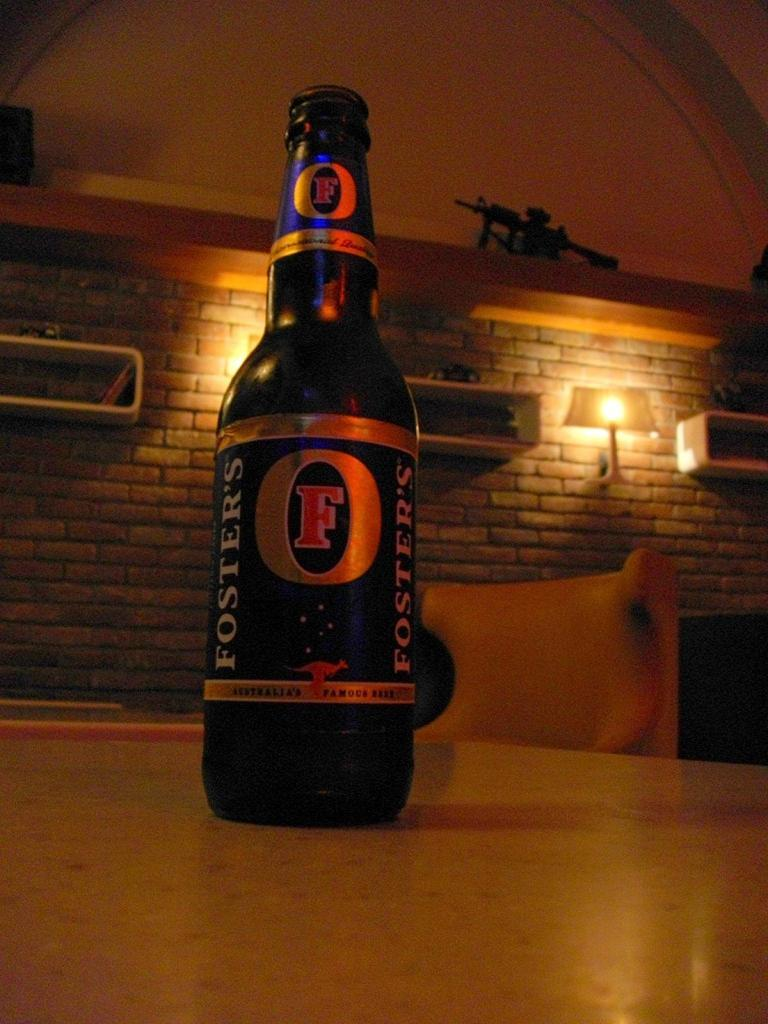<image>
Provide a brief description of the given image. A bottle of Fosters lager sitting on a table 